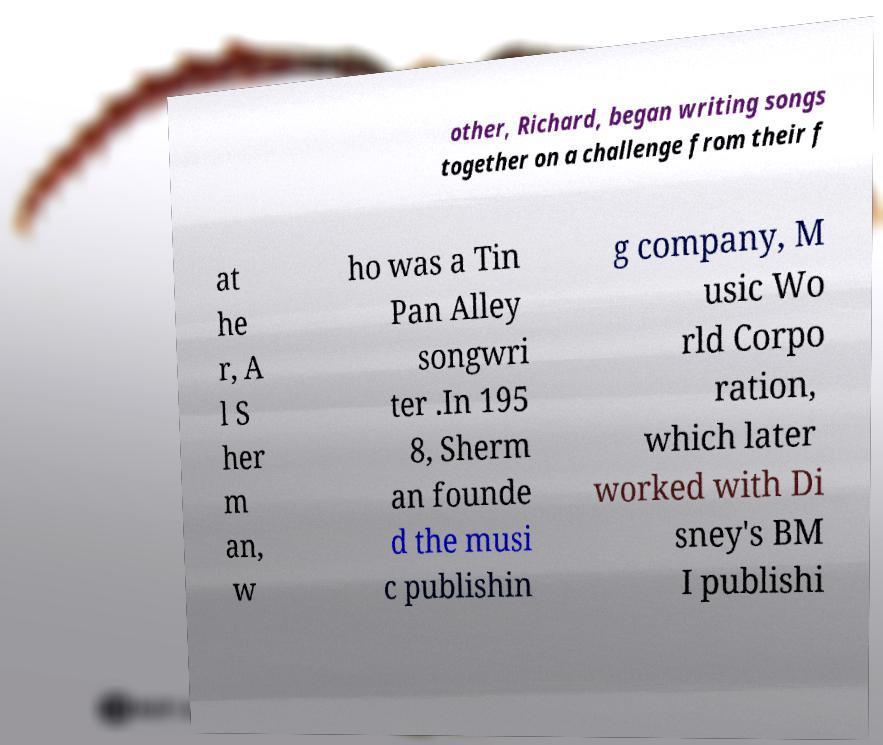Can you read and provide the text displayed in the image?This photo seems to have some interesting text. Can you extract and type it out for me? other, Richard, began writing songs together on a challenge from their f at he r, A l S her m an, w ho was a Tin Pan Alley songwri ter .In 195 8, Sherm an founde d the musi c publishin g company, M usic Wo rld Corpo ration, which later worked with Di sney's BM I publishi 